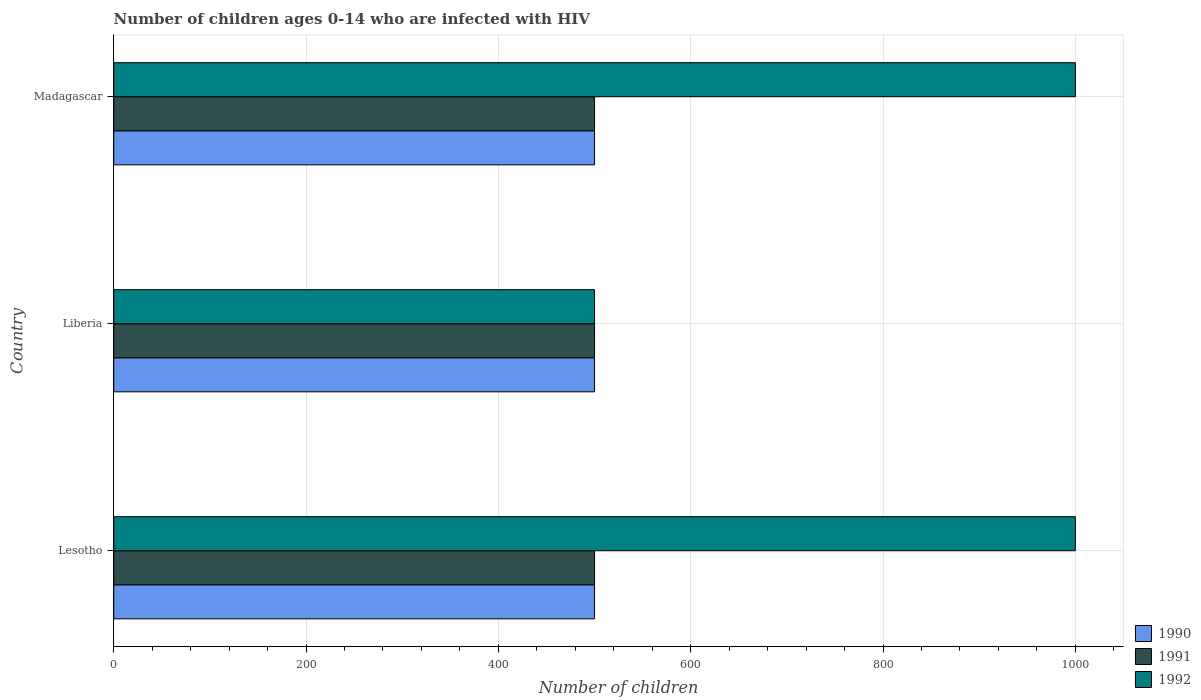How many groups of bars are there?
Give a very brief answer. 3. What is the label of the 3rd group of bars from the top?
Provide a short and direct response. Lesotho. In how many cases, is the number of bars for a given country not equal to the number of legend labels?
Keep it short and to the point. 0. What is the number of HIV infected children in 1991 in Lesotho?
Your response must be concise. 500. Across all countries, what is the maximum number of HIV infected children in 1990?
Make the answer very short. 500. Across all countries, what is the minimum number of HIV infected children in 1991?
Offer a very short reply. 500. In which country was the number of HIV infected children in 1990 maximum?
Your answer should be compact. Lesotho. In which country was the number of HIV infected children in 1991 minimum?
Make the answer very short. Lesotho. What is the total number of HIV infected children in 1991 in the graph?
Provide a succinct answer. 1500. What is the difference between the number of HIV infected children in 1992 in Lesotho and that in Liberia?
Your response must be concise. 500. What is the difference between the number of HIV infected children in 1991 in Liberia and the number of HIV infected children in 1990 in Madagascar?
Your answer should be very brief. 0. What is the difference between the number of HIV infected children in 1990 and number of HIV infected children in 1991 in Lesotho?
Offer a very short reply. 0. In how many countries, is the number of HIV infected children in 1992 greater than 560 ?
Ensure brevity in your answer.  2. Is the number of HIV infected children in 1991 in Lesotho less than that in Madagascar?
Offer a terse response. No. What is the difference between the highest and the second highest number of HIV infected children in 1990?
Your response must be concise. 0. What is the difference between the highest and the lowest number of HIV infected children in 1991?
Your answer should be very brief. 0. What does the 2nd bar from the bottom in Liberia represents?
Offer a terse response. 1991. Is it the case that in every country, the sum of the number of HIV infected children in 1991 and number of HIV infected children in 1990 is greater than the number of HIV infected children in 1992?
Provide a succinct answer. No. How many bars are there?
Give a very brief answer. 9. What is the difference between two consecutive major ticks on the X-axis?
Your answer should be compact. 200. Does the graph contain any zero values?
Your answer should be compact. No. Does the graph contain grids?
Offer a terse response. Yes. Where does the legend appear in the graph?
Your response must be concise. Bottom right. How many legend labels are there?
Make the answer very short. 3. What is the title of the graph?
Your answer should be very brief. Number of children ages 0-14 who are infected with HIV. Does "2009" appear as one of the legend labels in the graph?
Offer a very short reply. No. What is the label or title of the X-axis?
Provide a short and direct response. Number of children. What is the Number of children in 1990 in Lesotho?
Offer a terse response. 500. What is the Number of children in 1991 in Lesotho?
Provide a succinct answer. 500. What is the Number of children in 1990 in Liberia?
Provide a short and direct response. 500. What is the Number of children in 1991 in Liberia?
Offer a terse response. 500. What is the Number of children in 1992 in Liberia?
Offer a terse response. 500. What is the Number of children in 1990 in Madagascar?
Give a very brief answer. 500. What is the Number of children of 1992 in Madagascar?
Keep it short and to the point. 1000. Across all countries, what is the maximum Number of children in 1991?
Your answer should be compact. 500. Across all countries, what is the minimum Number of children in 1990?
Offer a very short reply. 500. Across all countries, what is the minimum Number of children in 1991?
Offer a very short reply. 500. Across all countries, what is the minimum Number of children in 1992?
Give a very brief answer. 500. What is the total Number of children in 1990 in the graph?
Your answer should be very brief. 1500. What is the total Number of children of 1991 in the graph?
Ensure brevity in your answer.  1500. What is the total Number of children of 1992 in the graph?
Offer a very short reply. 2500. What is the difference between the Number of children of 1990 in Lesotho and that in Liberia?
Provide a short and direct response. 0. What is the difference between the Number of children in 1991 in Lesotho and that in Liberia?
Your response must be concise. 0. What is the difference between the Number of children in 1992 in Lesotho and that in Madagascar?
Keep it short and to the point. 0. What is the difference between the Number of children of 1991 in Liberia and that in Madagascar?
Your answer should be compact. 0. What is the difference between the Number of children of 1992 in Liberia and that in Madagascar?
Your response must be concise. -500. What is the difference between the Number of children of 1990 in Lesotho and the Number of children of 1992 in Liberia?
Offer a very short reply. 0. What is the difference between the Number of children of 1991 in Lesotho and the Number of children of 1992 in Liberia?
Your answer should be compact. 0. What is the difference between the Number of children in 1990 in Lesotho and the Number of children in 1991 in Madagascar?
Your answer should be compact. 0. What is the difference between the Number of children in 1990 in Lesotho and the Number of children in 1992 in Madagascar?
Your answer should be compact. -500. What is the difference between the Number of children of 1991 in Lesotho and the Number of children of 1992 in Madagascar?
Your answer should be compact. -500. What is the difference between the Number of children in 1990 in Liberia and the Number of children in 1992 in Madagascar?
Give a very brief answer. -500. What is the difference between the Number of children of 1991 in Liberia and the Number of children of 1992 in Madagascar?
Offer a terse response. -500. What is the average Number of children of 1991 per country?
Your response must be concise. 500. What is the average Number of children in 1992 per country?
Offer a very short reply. 833.33. What is the difference between the Number of children of 1990 and Number of children of 1991 in Lesotho?
Give a very brief answer. 0. What is the difference between the Number of children of 1990 and Number of children of 1992 in Lesotho?
Your answer should be compact. -500. What is the difference between the Number of children of 1991 and Number of children of 1992 in Lesotho?
Provide a short and direct response. -500. What is the difference between the Number of children in 1990 and Number of children in 1991 in Liberia?
Make the answer very short. 0. What is the difference between the Number of children of 1990 and Number of children of 1991 in Madagascar?
Your answer should be compact. 0. What is the difference between the Number of children in 1990 and Number of children in 1992 in Madagascar?
Ensure brevity in your answer.  -500. What is the difference between the Number of children in 1991 and Number of children in 1992 in Madagascar?
Provide a short and direct response. -500. What is the ratio of the Number of children of 1991 in Lesotho to that in Liberia?
Ensure brevity in your answer.  1. What is the ratio of the Number of children in 1992 in Lesotho to that in Liberia?
Keep it short and to the point. 2. What is the ratio of the Number of children in 1990 in Lesotho to that in Madagascar?
Ensure brevity in your answer.  1. What is the ratio of the Number of children in 1991 in Lesotho to that in Madagascar?
Keep it short and to the point. 1. What is the ratio of the Number of children in 1992 in Lesotho to that in Madagascar?
Your response must be concise. 1. What is the ratio of the Number of children of 1991 in Liberia to that in Madagascar?
Offer a very short reply. 1. What is the ratio of the Number of children of 1992 in Liberia to that in Madagascar?
Offer a terse response. 0.5. What is the difference between the highest and the second highest Number of children in 1990?
Offer a terse response. 0. What is the difference between the highest and the second highest Number of children in 1991?
Your answer should be compact. 0. What is the difference between the highest and the second highest Number of children in 1992?
Ensure brevity in your answer.  0. What is the difference between the highest and the lowest Number of children of 1990?
Provide a succinct answer. 0. What is the difference between the highest and the lowest Number of children in 1991?
Give a very brief answer. 0. 